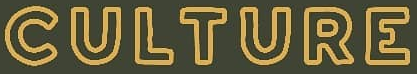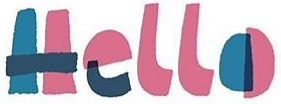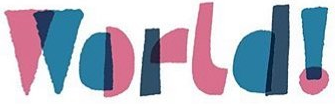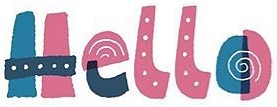Transcribe the words shown in these images in order, separated by a semicolon. CULTURE; Hello; World!; Hello 